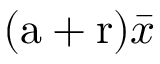Convert formula to latex. <formula><loc_0><loc_0><loc_500><loc_500>( a + r ) \bar { x }</formula> 